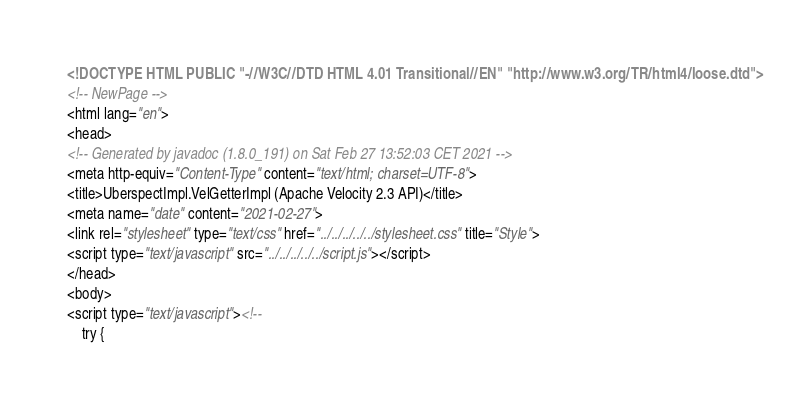Convert code to text. <code><loc_0><loc_0><loc_500><loc_500><_HTML_><!DOCTYPE HTML PUBLIC "-//W3C//DTD HTML 4.01 Transitional//EN" "http://www.w3.org/TR/html4/loose.dtd">
<!-- NewPage -->
<html lang="en">
<head>
<!-- Generated by javadoc (1.8.0_191) on Sat Feb 27 13:52:03 CET 2021 -->
<meta http-equiv="Content-Type" content="text/html; charset=UTF-8">
<title>UberspectImpl.VelGetterImpl (Apache Velocity 2.3 API)</title>
<meta name="date" content="2021-02-27">
<link rel="stylesheet" type="text/css" href="../../../../../stylesheet.css" title="Style">
<script type="text/javascript" src="../../../../../script.js"></script>
</head>
<body>
<script type="text/javascript"><!--
    try {</code> 